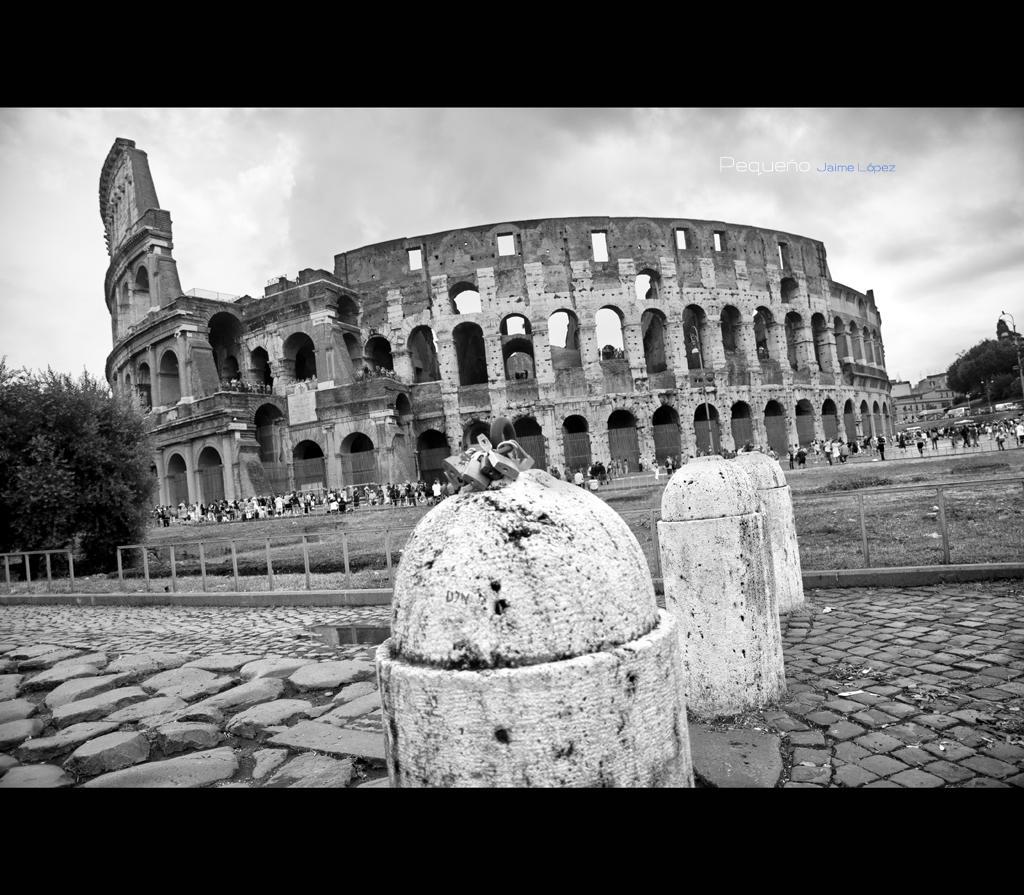Describe this image in one or two sentences. In this image we cam see black and white picture of a building with group of windows and arches and group of people standing on the ground. In the foreground we can see a group of poles. In the background, we can see some trees and cloudy sky and some text. 